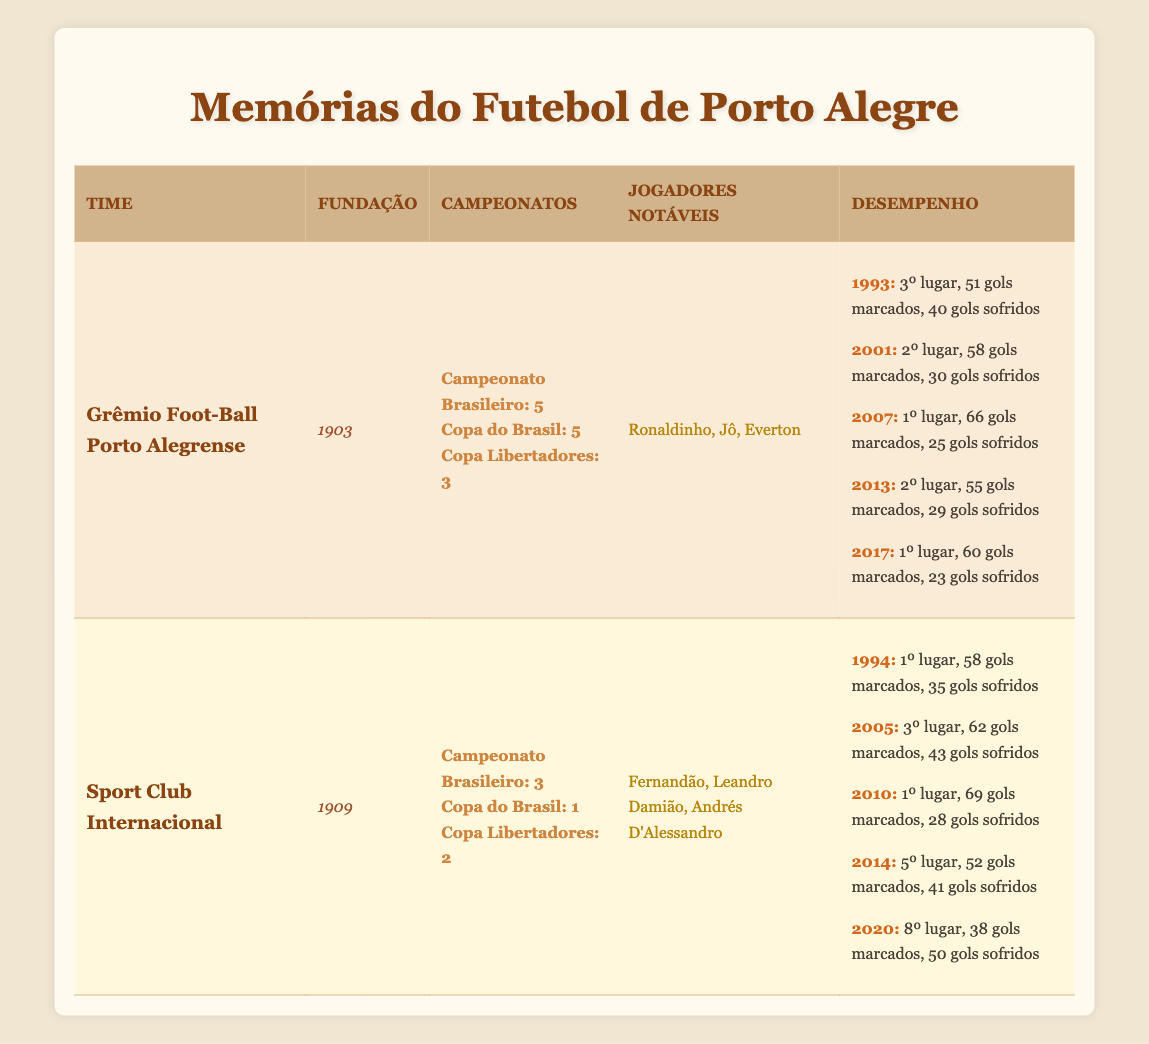What is the founding year of Grêmio Foot-Ball Porto Alegrense? The table lists the founding year of Grêmio as 1903.
Answer: 1903 How many championships has Sport Club Internacional won in the Copa do Brasil? The table states that Internacional has won 1 Copa do Brasil.
Answer: 1 Which team scored the most goals in a single year based on the performance data? Looking through the performance data, Internacional scored 69 goals in 2010, which is the highest among all listed performances.
Answer: 69 True or False: Grêmio has won more Copa Libertadores titles than Internacional. The table shows that Grêmio has won 3 Copa Libertadores titles and Internacional has won 2, so the statement is true.
Answer: True What is the league position of Grêmio in 2017? The performance data indicates that Grêmio was in 1st place in 2017.
Answer: 1st place Calculate the average number of goals scored by Sport Club Internacional across the years listed. To find the average, we first sum the goals scored: 58 + 62 + 69 + 52 + 38 = 279. There are 5 years, so the average is 279 / 5 = 55.8.
Answer: 55.8 What year did Grêmio last achieve a 1st place position? By looking at the performance years, Grêmio achieved 1st place in 2007 and again in 2017, with the last occurrence being in 2017.
Answer: 2017 How many goals did Grêmio score in total across the listed years? Adding the goals scored in the performance years: 51 + 58 + 66 + 55 + 60 = 290.
Answer: 290 What is the league position of Internacional in 2014? The table indicates that Internacional was in 5th place in 2014.
Answer: 5th place 